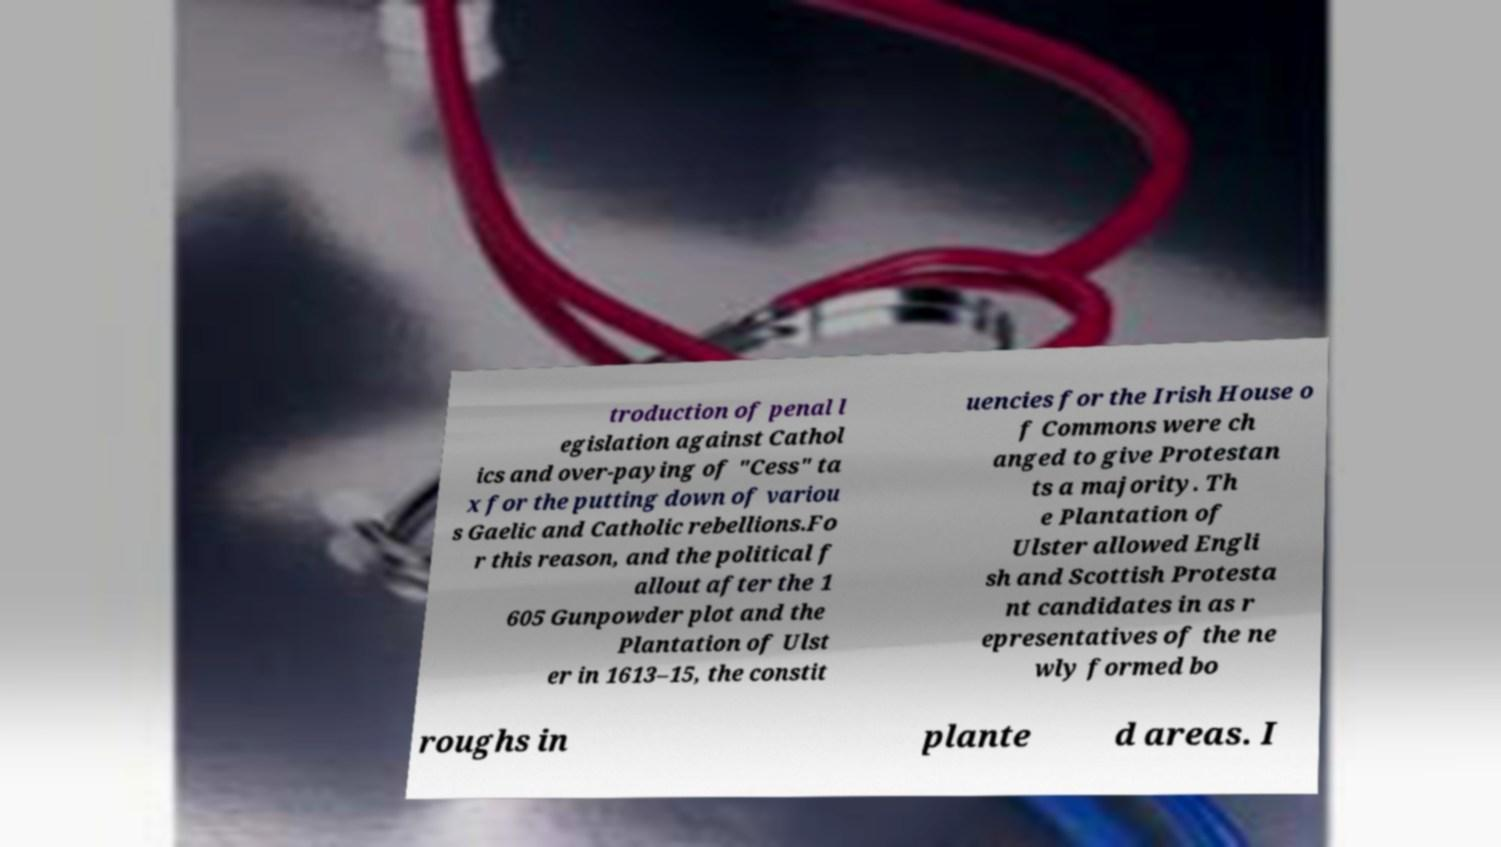Please identify and transcribe the text found in this image. troduction of penal l egislation against Cathol ics and over-paying of "Cess" ta x for the putting down of variou s Gaelic and Catholic rebellions.Fo r this reason, and the political f allout after the 1 605 Gunpowder plot and the Plantation of Ulst er in 1613–15, the constit uencies for the Irish House o f Commons were ch anged to give Protestan ts a majority. Th e Plantation of Ulster allowed Engli sh and Scottish Protesta nt candidates in as r epresentatives of the ne wly formed bo roughs in plante d areas. I 